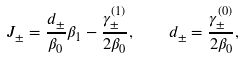<formula> <loc_0><loc_0><loc_500><loc_500>J _ { \pm } = \frac { d _ { \pm } } { \beta _ { 0 } } \beta _ { 1 } - \frac { \gamma ^ { ( 1 ) } _ { \pm } } { 2 \beta _ { 0 } } , \quad d _ { \pm } = \frac { \gamma ^ { ( 0 ) } _ { \pm } } { 2 \beta _ { 0 } } ,</formula> 